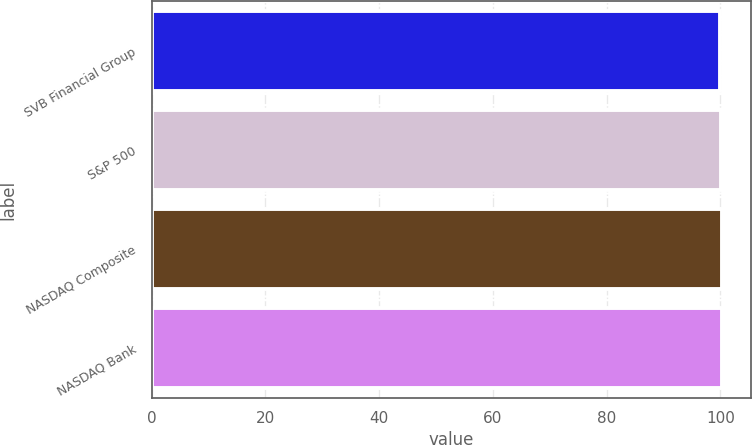Convert chart. <chart><loc_0><loc_0><loc_500><loc_500><bar_chart><fcel>SVB Financial Group<fcel>S&P 500<fcel>NASDAQ Composite<fcel>NASDAQ Bank<nl><fcel>100<fcel>100.1<fcel>100.2<fcel>100.3<nl></chart> 